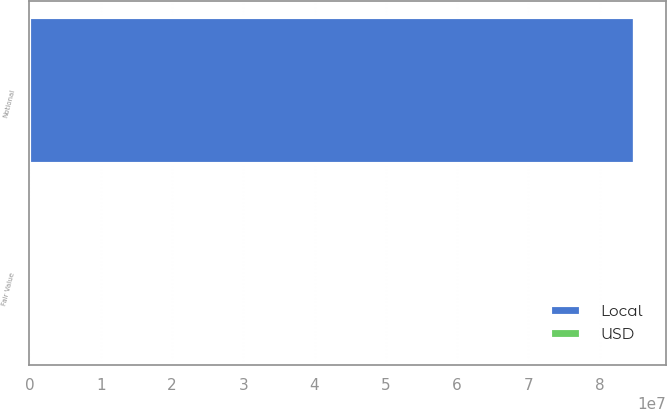Convert chart to OTSL. <chart><loc_0><loc_0><loc_500><loc_500><stacked_bar_chart><ecel><fcel>Notional<fcel>Fair Value<nl><fcel>Local<fcel>8.5e+07<fcel>8763<nl><fcel>USD<fcel>28327<fcel>3<nl></chart> 